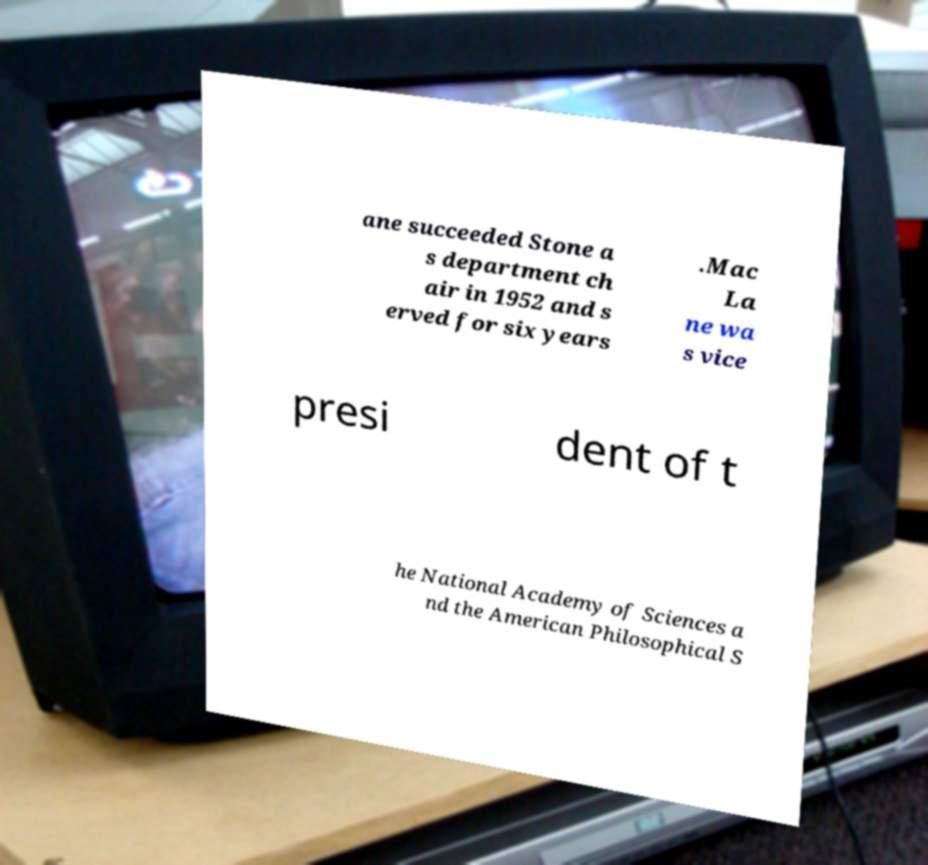Please identify and transcribe the text found in this image. ane succeeded Stone a s department ch air in 1952 and s erved for six years .Mac La ne wa s vice presi dent of t he National Academy of Sciences a nd the American Philosophical S 